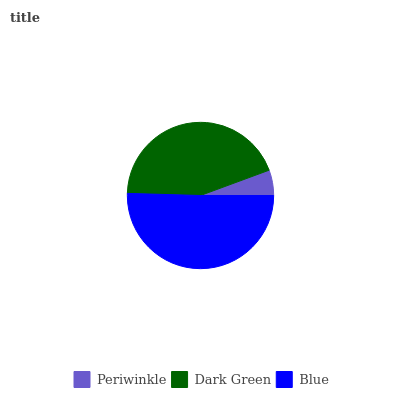Is Periwinkle the minimum?
Answer yes or no. Yes. Is Blue the maximum?
Answer yes or no. Yes. Is Dark Green the minimum?
Answer yes or no. No. Is Dark Green the maximum?
Answer yes or no. No. Is Dark Green greater than Periwinkle?
Answer yes or no. Yes. Is Periwinkle less than Dark Green?
Answer yes or no. Yes. Is Periwinkle greater than Dark Green?
Answer yes or no. No. Is Dark Green less than Periwinkle?
Answer yes or no. No. Is Dark Green the high median?
Answer yes or no. Yes. Is Dark Green the low median?
Answer yes or no. Yes. Is Periwinkle the high median?
Answer yes or no. No. Is Blue the low median?
Answer yes or no. No. 